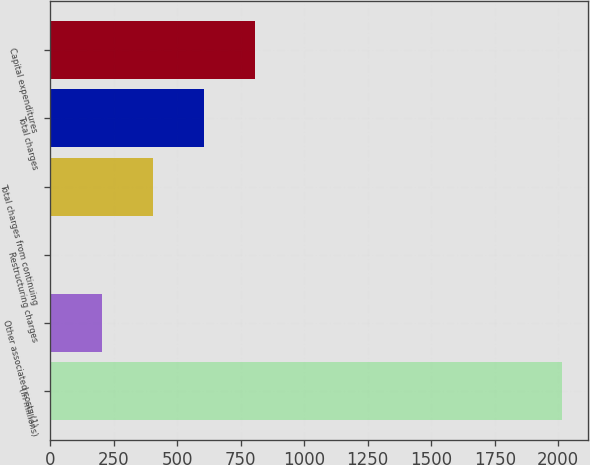Convert chart to OTSL. <chart><loc_0><loc_0><loc_500><loc_500><bar_chart><fcel>(In millions)<fcel>Other associated costs (1)<fcel>Restructuring charges<fcel>Total charges from continuing<fcel>Total charges<fcel>Capital expenditures<nl><fcel>2016<fcel>203.85<fcel>2.5<fcel>405.2<fcel>606.55<fcel>807.9<nl></chart> 